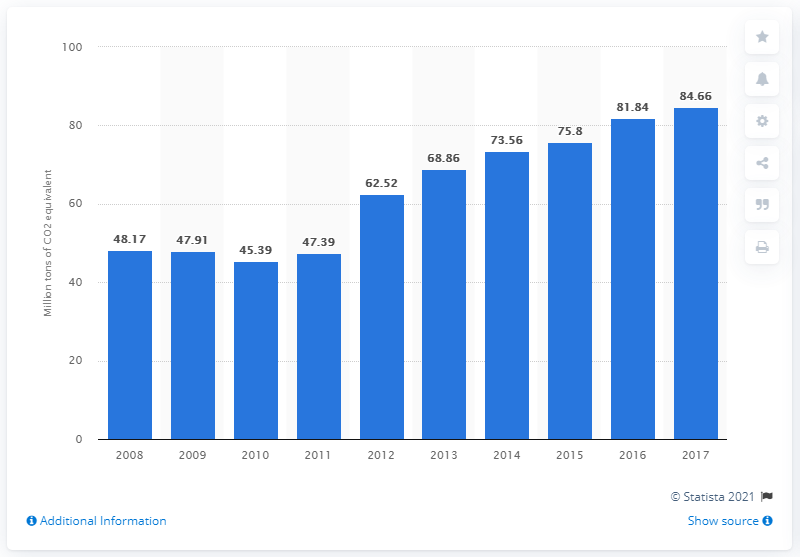Give some essential details in this illustration. In 2017, the production of CO2 equivalent through fuel combustion in Turkey was 84.66... 